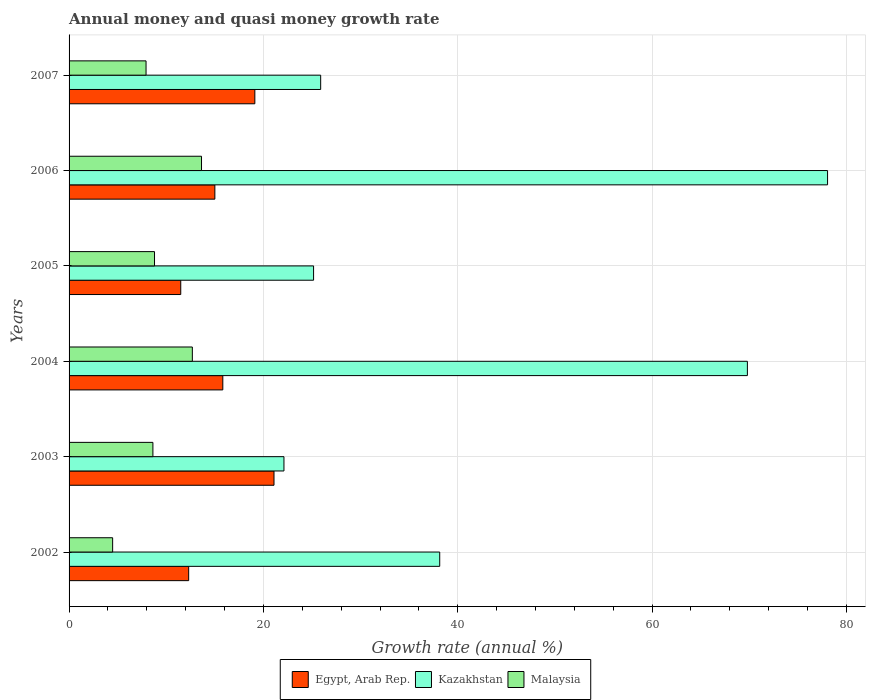How many different coloured bars are there?
Keep it short and to the point. 3. Are the number of bars on each tick of the Y-axis equal?
Make the answer very short. Yes. What is the growth rate in Malaysia in 2005?
Offer a terse response. 8.79. Across all years, what is the maximum growth rate in Malaysia?
Your answer should be compact. 13.63. Across all years, what is the minimum growth rate in Kazakhstan?
Offer a very short reply. 22.12. What is the total growth rate in Malaysia in the graph?
Offer a terse response. 56.15. What is the difference between the growth rate in Kazakhstan in 2003 and that in 2004?
Provide a succinct answer. -47.69. What is the difference between the growth rate in Egypt, Arab Rep. in 2007 and the growth rate in Kazakhstan in 2002?
Offer a terse response. -19.03. What is the average growth rate in Egypt, Arab Rep. per year?
Your answer should be compact. 15.81. In the year 2002, what is the difference between the growth rate in Kazakhstan and growth rate in Malaysia?
Offer a very short reply. 33.66. What is the ratio of the growth rate in Malaysia in 2003 to that in 2004?
Keep it short and to the point. 0.68. Is the growth rate in Kazakhstan in 2003 less than that in 2006?
Your response must be concise. Yes. Is the difference between the growth rate in Kazakhstan in 2004 and 2005 greater than the difference between the growth rate in Malaysia in 2004 and 2005?
Your response must be concise. Yes. What is the difference between the highest and the second highest growth rate in Kazakhstan?
Your answer should be very brief. 8.25. What is the difference between the highest and the lowest growth rate in Kazakhstan?
Your answer should be very brief. 55.95. In how many years, is the growth rate in Egypt, Arab Rep. greater than the average growth rate in Egypt, Arab Rep. taken over all years?
Offer a terse response. 3. What does the 2nd bar from the top in 2003 represents?
Offer a terse response. Kazakhstan. What does the 2nd bar from the bottom in 2002 represents?
Your response must be concise. Kazakhstan. How many bars are there?
Provide a succinct answer. 18. What is the difference between two consecutive major ticks on the X-axis?
Provide a short and direct response. 20. Are the values on the major ticks of X-axis written in scientific E-notation?
Offer a terse response. No. Does the graph contain any zero values?
Keep it short and to the point. No. Does the graph contain grids?
Your answer should be very brief. Yes. How many legend labels are there?
Offer a very short reply. 3. How are the legend labels stacked?
Offer a terse response. Horizontal. What is the title of the graph?
Keep it short and to the point. Annual money and quasi money growth rate. Does "OECD members" appear as one of the legend labels in the graph?
Give a very brief answer. No. What is the label or title of the X-axis?
Your answer should be very brief. Growth rate (annual %). What is the Growth rate (annual %) of Egypt, Arab Rep. in 2002?
Your answer should be compact. 12.31. What is the Growth rate (annual %) of Kazakhstan in 2002?
Ensure brevity in your answer.  38.15. What is the Growth rate (annual %) in Malaysia in 2002?
Offer a terse response. 4.48. What is the Growth rate (annual %) of Egypt, Arab Rep. in 2003?
Give a very brief answer. 21.09. What is the Growth rate (annual %) of Kazakhstan in 2003?
Ensure brevity in your answer.  22.12. What is the Growth rate (annual %) in Malaysia in 2003?
Provide a short and direct response. 8.63. What is the Growth rate (annual %) of Egypt, Arab Rep. in 2004?
Your response must be concise. 15.82. What is the Growth rate (annual %) of Kazakhstan in 2004?
Your answer should be very brief. 69.81. What is the Growth rate (annual %) in Malaysia in 2004?
Make the answer very short. 12.69. What is the Growth rate (annual %) in Egypt, Arab Rep. in 2005?
Provide a short and direct response. 11.49. What is the Growth rate (annual %) of Kazakhstan in 2005?
Keep it short and to the point. 25.16. What is the Growth rate (annual %) in Malaysia in 2005?
Provide a succinct answer. 8.79. What is the Growth rate (annual %) in Egypt, Arab Rep. in 2006?
Your answer should be very brief. 15. What is the Growth rate (annual %) in Kazakhstan in 2006?
Offer a very short reply. 78.06. What is the Growth rate (annual %) in Malaysia in 2006?
Ensure brevity in your answer.  13.63. What is the Growth rate (annual %) of Egypt, Arab Rep. in 2007?
Keep it short and to the point. 19.12. What is the Growth rate (annual %) in Kazakhstan in 2007?
Offer a terse response. 25.89. What is the Growth rate (annual %) in Malaysia in 2007?
Ensure brevity in your answer.  7.92. Across all years, what is the maximum Growth rate (annual %) in Egypt, Arab Rep.?
Keep it short and to the point. 21.09. Across all years, what is the maximum Growth rate (annual %) of Kazakhstan?
Offer a terse response. 78.06. Across all years, what is the maximum Growth rate (annual %) of Malaysia?
Give a very brief answer. 13.63. Across all years, what is the minimum Growth rate (annual %) in Egypt, Arab Rep.?
Offer a very short reply. 11.49. Across all years, what is the minimum Growth rate (annual %) in Kazakhstan?
Your answer should be compact. 22.12. Across all years, what is the minimum Growth rate (annual %) of Malaysia?
Your response must be concise. 4.48. What is the total Growth rate (annual %) of Egypt, Arab Rep. in the graph?
Keep it short and to the point. 94.84. What is the total Growth rate (annual %) in Kazakhstan in the graph?
Your answer should be compact. 259.19. What is the total Growth rate (annual %) of Malaysia in the graph?
Make the answer very short. 56.15. What is the difference between the Growth rate (annual %) in Egypt, Arab Rep. in 2002 and that in 2003?
Give a very brief answer. -8.78. What is the difference between the Growth rate (annual %) in Kazakhstan in 2002 and that in 2003?
Give a very brief answer. 16.03. What is the difference between the Growth rate (annual %) in Malaysia in 2002 and that in 2003?
Offer a very short reply. -4.14. What is the difference between the Growth rate (annual %) of Egypt, Arab Rep. in 2002 and that in 2004?
Provide a short and direct response. -3.51. What is the difference between the Growth rate (annual %) in Kazakhstan in 2002 and that in 2004?
Your answer should be compact. -31.66. What is the difference between the Growth rate (annual %) in Malaysia in 2002 and that in 2004?
Your response must be concise. -8.2. What is the difference between the Growth rate (annual %) of Egypt, Arab Rep. in 2002 and that in 2005?
Give a very brief answer. 0.82. What is the difference between the Growth rate (annual %) of Kazakhstan in 2002 and that in 2005?
Offer a very short reply. 12.98. What is the difference between the Growth rate (annual %) in Malaysia in 2002 and that in 2005?
Your response must be concise. -4.31. What is the difference between the Growth rate (annual %) in Egypt, Arab Rep. in 2002 and that in 2006?
Offer a terse response. -2.7. What is the difference between the Growth rate (annual %) in Kazakhstan in 2002 and that in 2006?
Provide a short and direct response. -39.91. What is the difference between the Growth rate (annual %) of Malaysia in 2002 and that in 2006?
Provide a succinct answer. -9.15. What is the difference between the Growth rate (annual %) of Egypt, Arab Rep. in 2002 and that in 2007?
Offer a very short reply. -6.81. What is the difference between the Growth rate (annual %) of Kazakhstan in 2002 and that in 2007?
Make the answer very short. 12.25. What is the difference between the Growth rate (annual %) of Malaysia in 2002 and that in 2007?
Offer a terse response. -3.44. What is the difference between the Growth rate (annual %) in Egypt, Arab Rep. in 2003 and that in 2004?
Provide a succinct answer. 5.27. What is the difference between the Growth rate (annual %) of Kazakhstan in 2003 and that in 2004?
Keep it short and to the point. -47.69. What is the difference between the Growth rate (annual %) of Malaysia in 2003 and that in 2004?
Provide a short and direct response. -4.06. What is the difference between the Growth rate (annual %) of Egypt, Arab Rep. in 2003 and that in 2005?
Your response must be concise. 9.6. What is the difference between the Growth rate (annual %) in Kazakhstan in 2003 and that in 2005?
Ensure brevity in your answer.  -3.05. What is the difference between the Growth rate (annual %) of Malaysia in 2003 and that in 2005?
Ensure brevity in your answer.  -0.17. What is the difference between the Growth rate (annual %) of Egypt, Arab Rep. in 2003 and that in 2006?
Your answer should be very brief. 6.09. What is the difference between the Growth rate (annual %) in Kazakhstan in 2003 and that in 2006?
Offer a terse response. -55.95. What is the difference between the Growth rate (annual %) in Malaysia in 2003 and that in 2006?
Your answer should be compact. -5. What is the difference between the Growth rate (annual %) in Egypt, Arab Rep. in 2003 and that in 2007?
Provide a succinct answer. 1.97. What is the difference between the Growth rate (annual %) in Kazakhstan in 2003 and that in 2007?
Offer a very short reply. -3.78. What is the difference between the Growth rate (annual %) in Malaysia in 2003 and that in 2007?
Your answer should be compact. 0.7. What is the difference between the Growth rate (annual %) of Egypt, Arab Rep. in 2004 and that in 2005?
Give a very brief answer. 4.33. What is the difference between the Growth rate (annual %) in Kazakhstan in 2004 and that in 2005?
Offer a terse response. 44.64. What is the difference between the Growth rate (annual %) in Malaysia in 2004 and that in 2005?
Give a very brief answer. 3.89. What is the difference between the Growth rate (annual %) of Egypt, Arab Rep. in 2004 and that in 2006?
Make the answer very short. 0.82. What is the difference between the Growth rate (annual %) in Kazakhstan in 2004 and that in 2006?
Your answer should be compact. -8.25. What is the difference between the Growth rate (annual %) of Malaysia in 2004 and that in 2006?
Offer a very short reply. -0.94. What is the difference between the Growth rate (annual %) of Egypt, Arab Rep. in 2004 and that in 2007?
Ensure brevity in your answer.  -3.3. What is the difference between the Growth rate (annual %) of Kazakhstan in 2004 and that in 2007?
Provide a succinct answer. 43.91. What is the difference between the Growth rate (annual %) of Malaysia in 2004 and that in 2007?
Keep it short and to the point. 4.76. What is the difference between the Growth rate (annual %) of Egypt, Arab Rep. in 2005 and that in 2006?
Keep it short and to the point. -3.51. What is the difference between the Growth rate (annual %) in Kazakhstan in 2005 and that in 2006?
Your answer should be very brief. -52.9. What is the difference between the Growth rate (annual %) of Malaysia in 2005 and that in 2006?
Provide a short and direct response. -4.84. What is the difference between the Growth rate (annual %) of Egypt, Arab Rep. in 2005 and that in 2007?
Your response must be concise. -7.63. What is the difference between the Growth rate (annual %) in Kazakhstan in 2005 and that in 2007?
Make the answer very short. -0.73. What is the difference between the Growth rate (annual %) of Malaysia in 2005 and that in 2007?
Provide a succinct answer. 0.87. What is the difference between the Growth rate (annual %) of Egypt, Arab Rep. in 2006 and that in 2007?
Offer a terse response. -4.11. What is the difference between the Growth rate (annual %) of Kazakhstan in 2006 and that in 2007?
Your answer should be very brief. 52.17. What is the difference between the Growth rate (annual %) in Malaysia in 2006 and that in 2007?
Provide a short and direct response. 5.71. What is the difference between the Growth rate (annual %) in Egypt, Arab Rep. in 2002 and the Growth rate (annual %) in Kazakhstan in 2003?
Your answer should be compact. -9.81. What is the difference between the Growth rate (annual %) of Egypt, Arab Rep. in 2002 and the Growth rate (annual %) of Malaysia in 2003?
Provide a short and direct response. 3.68. What is the difference between the Growth rate (annual %) in Kazakhstan in 2002 and the Growth rate (annual %) in Malaysia in 2003?
Offer a very short reply. 29.52. What is the difference between the Growth rate (annual %) in Egypt, Arab Rep. in 2002 and the Growth rate (annual %) in Kazakhstan in 2004?
Offer a very short reply. -57.5. What is the difference between the Growth rate (annual %) of Egypt, Arab Rep. in 2002 and the Growth rate (annual %) of Malaysia in 2004?
Offer a very short reply. -0.38. What is the difference between the Growth rate (annual %) of Kazakhstan in 2002 and the Growth rate (annual %) of Malaysia in 2004?
Keep it short and to the point. 25.46. What is the difference between the Growth rate (annual %) in Egypt, Arab Rep. in 2002 and the Growth rate (annual %) in Kazakhstan in 2005?
Your response must be concise. -12.86. What is the difference between the Growth rate (annual %) of Egypt, Arab Rep. in 2002 and the Growth rate (annual %) of Malaysia in 2005?
Provide a short and direct response. 3.52. What is the difference between the Growth rate (annual %) of Kazakhstan in 2002 and the Growth rate (annual %) of Malaysia in 2005?
Provide a succinct answer. 29.35. What is the difference between the Growth rate (annual %) of Egypt, Arab Rep. in 2002 and the Growth rate (annual %) of Kazakhstan in 2006?
Your response must be concise. -65.75. What is the difference between the Growth rate (annual %) of Egypt, Arab Rep. in 2002 and the Growth rate (annual %) of Malaysia in 2006?
Offer a very short reply. -1.32. What is the difference between the Growth rate (annual %) in Kazakhstan in 2002 and the Growth rate (annual %) in Malaysia in 2006?
Offer a very short reply. 24.51. What is the difference between the Growth rate (annual %) in Egypt, Arab Rep. in 2002 and the Growth rate (annual %) in Kazakhstan in 2007?
Give a very brief answer. -13.59. What is the difference between the Growth rate (annual %) of Egypt, Arab Rep. in 2002 and the Growth rate (annual %) of Malaysia in 2007?
Make the answer very short. 4.39. What is the difference between the Growth rate (annual %) in Kazakhstan in 2002 and the Growth rate (annual %) in Malaysia in 2007?
Make the answer very short. 30.22. What is the difference between the Growth rate (annual %) in Egypt, Arab Rep. in 2003 and the Growth rate (annual %) in Kazakhstan in 2004?
Provide a succinct answer. -48.72. What is the difference between the Growth rate (annual %) of Egypt, Arab Rep. in 2003 and the Growth rate (annual %) of Malaysia in 2004?
Your answer should be compact. 8.4. What is the difference between the Growth rate (annual %) in Kazakhstan in 2003 and the Growth rate (annual %) in Malaysia in 2004?
Give a very brief answer. 9.43. What is the difference between the Growth rate (annual %) of Egypt, Arab Rep. in 2003 and the Growth rate (annual %) of Kazakhstan in 2005?
Ensure brevity in your answer.  -4.07. What is the difference between the Growth rate (annual %) in Egypt, Arab Rep. in 2003 and the Growth rate (annual %) in Malaysia in 2005?
Provide a short and direct response. 12.3. What is the difference between the Growth rate (annual %) of Kazakhstan in 2003 and the Growth rate (annual %) of Malaysia in 2005?
Offer a terse response. 13.32. What is the difference between the Growth rate (annual %) of Egypt, Arab Rep. in 2003 and the Growth rate (annual %) of Kazakhstan in 2006?
Make the answer very short. -56.97. What is the difference between the Growth rate (annual %) in Egypt, Arab Rep. in 2003 and the Growth rate (annual %) in Malaysia in 2006?
Your answer should be very brief. 7.46. What is the difference between the Growth rate (annual %) of Kazakhstan in 2003 and the Growth rate (annual %) of Malaysia in 2006?
Offer a terse response. 8.48. What is the difference between the Growth rate (annual %) in Egypt, Arab Rep. in 2003 and the Growth rate (annual %) in Kazakhstan in 2007?
Ensure brevity in your answer.  -4.8. What is the difference between the Growth rate (annual %) of Egypt, Arab Rep. in 2003 and the Growth rate (annual %) of Malaysia in 2007?
Your answer should be compact. 13.17. What is the difference between the Growth rate (annual %) in Kazakhstan in 2003 and the Growth rate (annual %) in Malaysia in 2007?
Provide a succinct answer. 14.19. What is the difference between the Growth rate (annual %) in Egypt, Arab Rep. in 2004 and the Growth rate (annual %) in Kazakhstan in 2005?
Provide a succinct answer. -9.34. What is the difference between the Growth rate (annual %) in Egypt, Arab Rep. in 2004 and the Growth rate (annual %) in Malaysia in 2005?
Your answer should be very brief. 7.03. What is the difference between the Growth rate (annual %) in Kazakhstan in 2004 and the Growth rate (annual %) in Malaysia in 2005?
Make the answer very short. 61.02. What is the difference between the Growth rate (annual %) of Egypt, Arab Rep. in 2004 and the Growth rate (annual %) of Kazakhstan in 2006?
Provide a succinct answer. -62.24. What is the difference between the Growth rate (annual %) in Egypt, Arab Rep. in 2004 and the Growth rate (annual %) in Malaysia in 2006?
Keep it short and to the point. 2.19. What is the difference between the Growth rate (annual %) in Kazakhstan in 2004 and the Growth rate (annual %) in Malaysia in 2006?
Ensure brevity in your answer.  56.18. What is the difference between the Growth rate (annual %) in Egypt, Arab Rep. in 2004 and the Growth rate (annual %) in Kazakhstan in 2007?
Make the answer very short. -10.07. What is the difference between the Growth rate (annual %) of Egypt, Arab Rep. in 2004 and the Growth rate (annual %) of Malaysia in 2007?
Provide a succinct answer. 7.9. What is the difference between the Growth rate (annual %) in Kazakhstan in 2004 and the Growth rate (annual %) in Malaysia in 2007?
Keep it short and to the point. 61.89. What is the difference between the Growth rate (annual %) of Egypt, Arab Rep. in 2005 and the Growth rate (annual %) of Kazakhstan in 2006?
Make the answer very short. -66.57. What is the difference between the Growth rate (annual %) in Egypt, Arab Rep. in 2005 and the Growth rate (annual %) in Malaysia in 2006?
Offer a very short reply. -2.14. What is the difference between the Growth rate (annual %) of Kazakhstan in 2005 and the Growth rate (annual %) of Malaysia in 2006?
Your answer should be very brief. 11.53. What is the difference between the Growth rate (annual %) of Egypt, Arab Rep. in 2005 and the Growth rate (annual %) of Kazakhstan in 2007?
Your response must be concise. -14.4. What is the difference between the Growth rate (annual %) in Egypt, Arab Rep. in 2005 and the Growth rate (annual %) in Malaysia in 2007?
Your answer should be very brief. 3.57. What is the difference between the Growth rate (annual %) in Kazakhstan in 2005 and the Growth rate (annual %) in Malaysia in 2007?
Provide a short and direct response. 17.24. What is the difference between the Growth rate (annual %) of Egypt, Arab Rep. in 2006 and the Growth rate (annual %) of Kazakhstan in 2007?
Ensure brevity in your answer.  -10.89. What is the difference between the Growth rate (annual %) of Egypt, Arab Rep. in 2006 and the Growth rate (annual %) of Malaysia in 2007?
Ensure brevity in your answer.  7.08. What is the difference between the Growth rate (annual %) in Kazakhstan in 2006 and the Growth rate (annual %) in Malaysia in 2007?
Your response must be concise. 70.14. What is the average Growth rate (annual %) of Egypt, Arab Rep. per year?
Offer a very short reply. 15.81. What is the average Growth rate (annual %) of Kazakhstan per year?
Offer a terse response. 43.2. What is the average Growth rate (annual %) in Malaysia per year?
Your answer should be very brief. 9.36. In the year 2002, what is the difference between the Growth rate (annual %) in Egypt, Arab Rep. and Growth rate (annual %) in Kazakhstan?
Provide a short and direct response. -25.84. In the year 2002, what is the difference between the Growth rate (annual %) in Egypt, Arab Rep. and Growth rate (annual %) in Malaysia?
Your answer should be compact. 7.82. In the year 2002, what is the difference between the Growth rate (annual %) in Kazakhstan and Growth rate (annual %) in Malaysia?
Your response must be concise. 33.66. In the year 2003, what is the difference between the Growth rate (annual %) in Egypt, Arab Rep. and Growth rate (annual %) in Kazakhstan?
Give a very brief answer. -1.02. In the year 2003, what is the difference between the Growth rate (annual %) of Egypt, Arab Rep. and Growth rate (annual %) of Malaysia?
Give a very brief answer. 12.46. In the year 2003, what is the difference between the Growth rate (annual %) in Kazakhstan and Growth rate (annual %) in Malaysia?
Offer a very short reply. 13.49. In the year 2004, what is the difference between the Growth rate (annual %) of Egypt, Arab Rep. and Growth rate (annual %) of Kazakhstan?
Offer a terse response. -53.99. In the year 2004, what is the difference between the Growth rate (annual %) of Egypt, Arab Rep. and Growth rate (annual %) of Malaysia?
Provide a succinct answer. 3.13. In the year 2004, what is the difference between the Growth rate (annual %) of Kazakhstan and Growth rate (annual %) of Malaysia?
Your answer should be compact. 57.12. In the year 2005, what is the difference between the Growth rate (annual %) of Egypt, Arab Rep. and Growth rate (annual %) of Kazakhstan?
Offer a terse response. -13.67. In the year 2005, what is the difference between the Growth rate (annual %) in Egypt, Arab Rep. and Growth rate (annual %) in Malaysia?
Give a very brief answer. 2.7. In the year 2005, what is the difference between the Growth rate (annual %) of Kazakhstan and Growth rate (annual %) of Malaysia?
Your answer should be very brief. 16.37. In the year 2006, what is the difference between the Growth rate (annual %) of Egypt, Arab Rep. and Growth rate (annual %) of Kazakhstan?
Provide a succinct answer. -63.06. In the year 2006, what is the difference between the Growth rate (annual %) in Egypt, Arab Rep. and Growth rate (annual %) in Malaysia?
Offer a very short reply. 1.37. In the year 2006, what is the difference between the Growth rate (annual %) in Kazakhstan and Growth rate (annual %) in Malaysia?
Your answer should be very brief. 64.43. In the year 2007, what is the difference between the Growth rate (annual %) in Egypt, Arab Rep. and Growth rate (annual %) in Kazakhstan?
Provide a short and direct response. -6.77. In the year 2007, what is the difference between the Growth rate (annual %) in Egypt, Arab Rep. and Growth rate (annual %) in Malaysia?
Make the answer very short. 11.2. In the year 2007, what is the difference between the Growth rate (annual %) of Kazakhstan and Growth rate (annual %) of Malaysia?
Your response must be concise. 17.97. What is the ratio of the Growth rate (annual %) in Egypt, Arab Rep. in 2002 to that in 2003?
Your answer should be compact. 0.58. What is the ratio of the Growth rate (annual %) in Kazakhstan in 2002 to that in 2003?
Give a very brief answer. 1.72. What is the ratio of the Growth rate (annual %) in Malaysia in 2002 to that in 2003?
Provide a short and direct response. 0.52. What is the ratio of the Growth rate (annual %) of Egypt, Arab Rep. in 2002 to that in 2004?
Ensure brevity in your answer.  0.78. What is the ratio of the Growth rate (annual %) of Kazakhstan in 2002 to that in 2004?
Ensure brevity in your answer.  0.55. What is the ratio of the Growth rate (annual %) of Malaysia in 2002 to that in 2004?
Offer a terse response. 0.35. What is the ratio of the Growth rate (annual %) of Egypt, Arab Rep. in 2002 to that in 2005?
Your answer should be very brief. 1.07. What is the ratio of the Growth rate (annual %) in Kazakhstan in 2002 to that in 2005?
Offer a terse response. 1.52. What is the ratio of the Growth rate (annual %) of Malaysia in 2002 to that in 2005?
Make the answer very short. 0.51. What is the ratio of the Growth rate (annual %) in Egypt, Arab Rep. in 2002 to that in 2006?
Provide a short and direct response. 0.82. What is the ratio of the Growth rate (annual %) of Kazakhstan in 2002 to that in 2006?
Your answer should be very brief. 0.49. What is the ratio of the Growth rate (annual %) of Malaysia in 2002 to that in 2006?
Ensure brevity in your answer.  0.33. What is the ratio of the Growth rate (annual %) of Egypt, Arab Rep. in 2002 to that in 2007?
Your response must be concise. 0.64. What is the ratio of the Growth rate (annual %) in Kazakhstan in 2002 to that in 2007?
Provide a short and direct response. 1.47. What is the ratio of the Growth rate (annual %) in Malaysia in 2002 to that in 2007?
Provide a succinct answer. 0.57. What is the ratio of the Growth rate (annual %) in Egypt, Arab Rep. in 2003 to that in 2004?
Offer a terse response. 1.33. What is the ratio of the Growth rate (annual %) of Kazakhstan in 2003 to that in 2004?
Your answer should be compact. 0.32. What is the ratio of the Growth rate (annual %) in Malaysia in 2003 to that in 2004?
Keep it short and to the point. 0.68. What is the ratio of the Growth rate (annual %) in Egypt, Arab Rep. in 2003 to that in 2005?
Provide a short and direct response. 1.83. What is the ratio of the Growth rate (annual %) of Kazakhstan in 2003 to that in 2005?
Make the answer very short. 0.88. What is the ratio of the Growth rate (annual %) in Malaysia in 2003 to that in 2005?
Give a very brief answer. 0.98. What is the ratio of the Growth rate (annual %) in Egypt, Arab Rep. in 2003 to that in 2006?
Give a very brief answer. 1.41. What is the ratio of the Growth rate (annual %) of Kazakhstan in 2003 to that in 2006?
Provide a succinct answer. 0.28. What is the ratio of the Growth rate (annual %) of Malaysia in 2003 to that in 2006?
Provide a succinct answer. 0.63. What is the ratio of the Growth rate (annual %) in Egypt, Arab Rep. in 2003 to that in 2007?
Keep it short and to the point. 1.1. What is the ratio of the Growth rate (annual %) in Kazakhstan in 2003 to that in 2007?
Keep it short and to the point. 0.85. What is the ratio of the Growth rate (annual %) in Malaysia in 2003 to that in 2007?
Offer a very short reply. 1.09. What is the ratio of the Growth rate (annual %) in Egypt, Arab Rep. in 2004 to that in 2005?
Ensure brevity in your answer.  1.38. What is the ratio of the Growth rate (annual %) in Kazakhstan in 2004 to that in 2005?
Give a very brief answer. 2.77. What is the ratio of the Growth rate (annual %) in Malaysia in 2004 to that in 2005?
Make the answer very short. 1.44. What is the ratio of the Growth rate (annual %) in Egypt, Arab Rep. in 2004 to that in 2006?
Make the answer very short. 1.05. What is the ratio of the Growth rate (annual %) in Kazakhstan in 2004 to that in 2006?
Your answer should be very brief. 0.89. What is the ratio of the Growth rate (annual %) in Malaysia in 2004 to that in 2006?
Provide a succinct answer. 0.93. What is the ratio of the Growth rate (annual %) of Egypt, Arab Rep. in 2004 to that in 2007?
Give a very brief answer. 0.83. What is the ratio of the Growth rate (annual %) of Kazakhstan in 2004 to that in 2007?
Your answer should be very brief. 2.7. What is the ratio of the Growth rate (annual %) of Malaysia in 2004 to that in 2007?
Ensure brevity in your answer.  1.6. What is the ratio of the Growth rate (annual %) in Egypt, Arab Rep. in 2005 to that in 2006?
Ensure brevity in your answer.  0.77. What is the ratio of the Growth rate (annual %) of Kazakhstan in 2005 to that in 2006?
Offer a very short reply. 0.32. What is the ratio of the Growth rate (annual %) of Malaysia in 2005 to that in 2006?
Offer a terse response. 0.65. What is the ratio of the Growth rate (annual %) of Egypt, Arab Rep. in 2005 to that in 2007?
Offer a terse response. 0.6. What is the ratio of the Growth rate (annual %) of Kazakhstan in 2005 to that in 2007?
Offer a terse response. 0.97. What is the ratio of the Growth rate (annual %) of Malaysia in 2005 to that in 2007?
Give a very brief answer. 1.11. What is the ratio of the Growth rate (annual %) of Egypt, Arab Rep. in 2006 to that in 2007?
Make the answer very short. 0.78. What is the ratio of the Growth rate (annual %) of Kazakhstan in 2006 to that in 2007?
Provide a succinct answer. 3.01. What is the ratio of the Growth rate (annual %) in Malaysia in 2006 to that in 2007?
Offer a very short reply. 1.72. What is the difference between the highest and the second highest Growth rate (annual %) of Egypt, Arab Rep.?
Your answer should be compact. 1.97. What is the difference between the highest and the second highest Growth rate (annual %) in Kazakhstan?
Provide a succinct answer. 8.25. What is the difference between the highest and the second highest Growth rate (annual %) of Malaysia?
Your answer should be compact. 0.94. What is the difference between the highest and the lowest Growth rate (annual %) in Egypt, Arab Rep.?
Keep it short and to the point. 9.6. What is the difference between the highest and the lowest Growth rate (annual %) of Kazakhstan?
Your response must be concise. 55.95. What is the difference between the highest and the lowest Growth rate (annual %) in Malaysia?
Offer a very short reply. 9.15. 